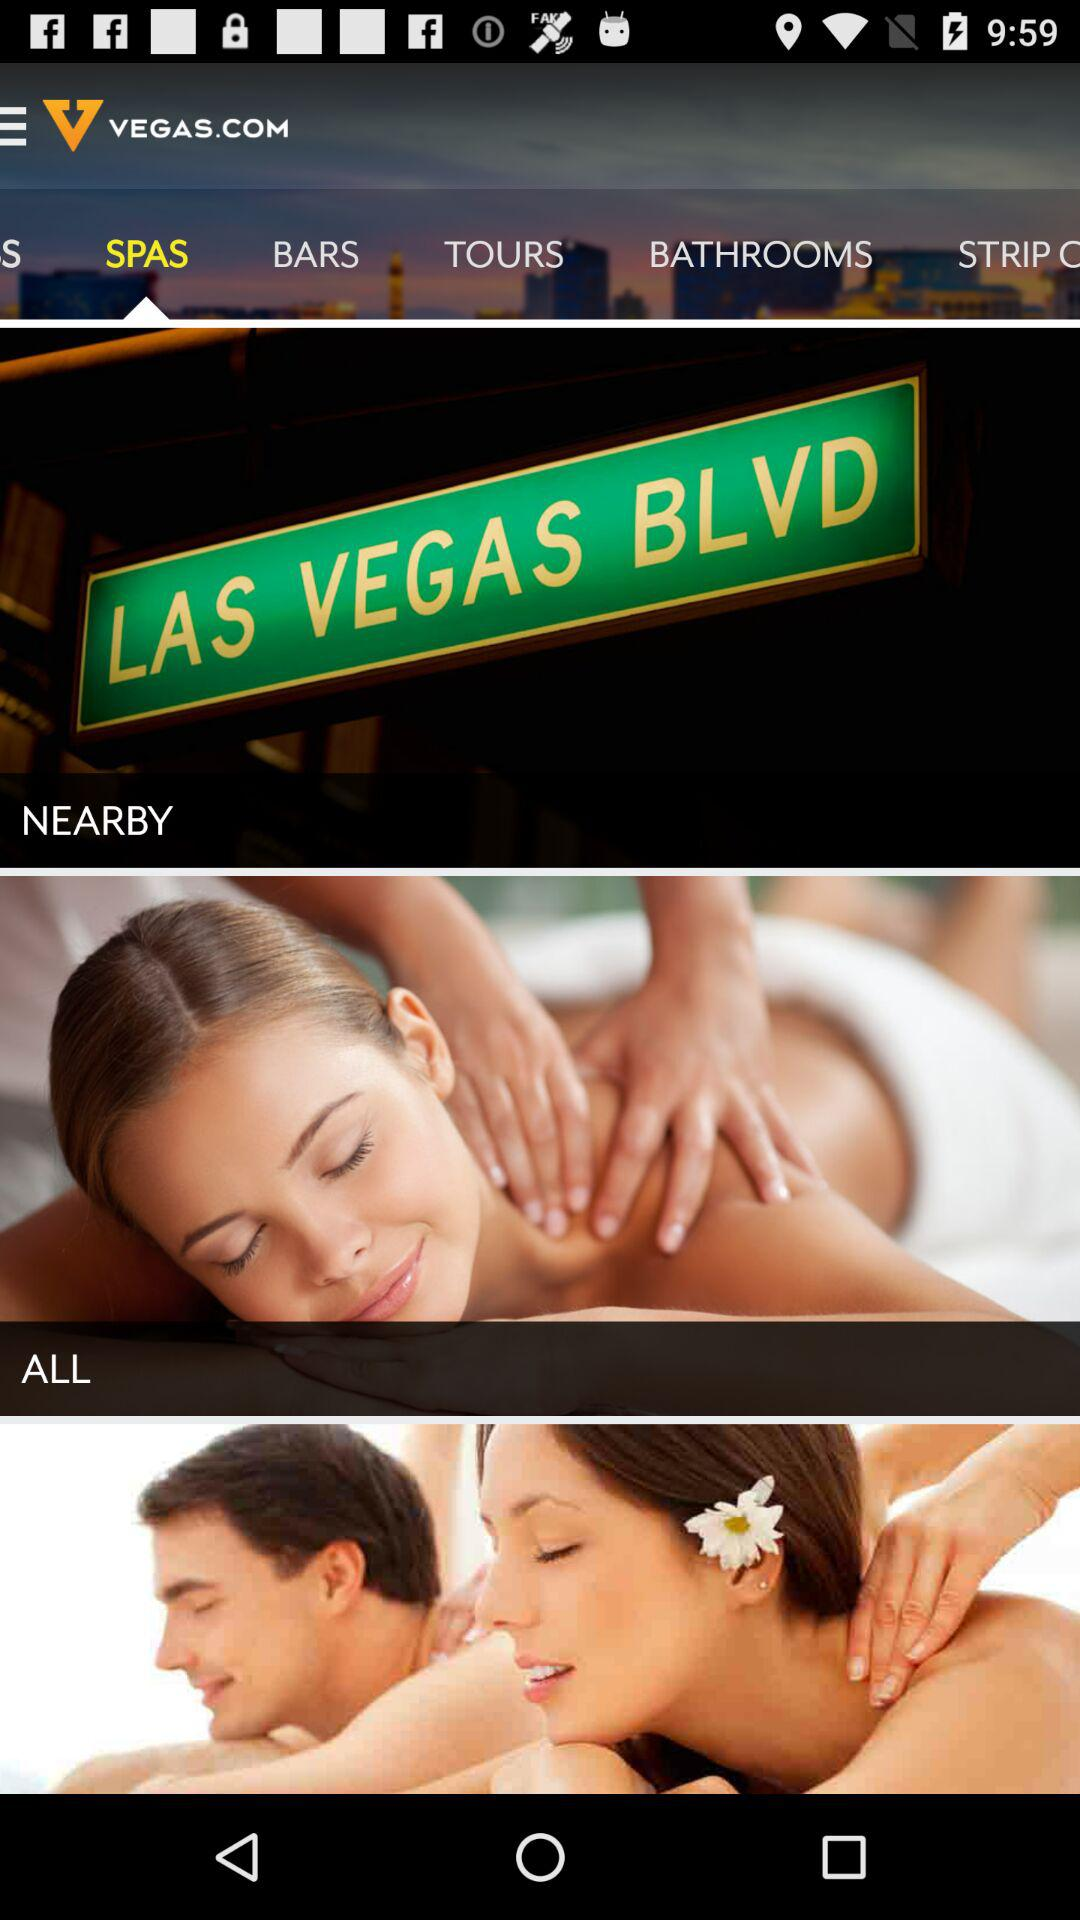What is the application name? The application name is "VEGAS.COM". 